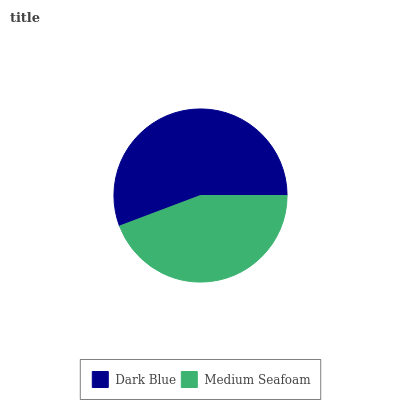Is Medium Seafoam the minimum?
Answer yes or no. Yes. Is Dark Blue the maximum?
Answer yes or no. Yes. Is Medium Seafoam the maximum?
Answer yes or no. No. Is Dark Blue greater than Medium Seafoam?
Answer yes or no. Yes. Is Medium Seafoam less than Dark Blue?
Answer yes or no. Yes. Is Medium Seafoam greater than Dark Blue?
Answer yes or no. No. Is Dark Blue less than Medium Seafoam?
Answer yes or no. No. Is Dark Blue the high median?
Answer yes or no. Yes. Is Medium Seafoam the low median?
Answer yes or no. Yes. Is Medium Seafoam the high median?
Answer yes or no. No. Is Dark Blue the low median?
Answer yes or no. No. 